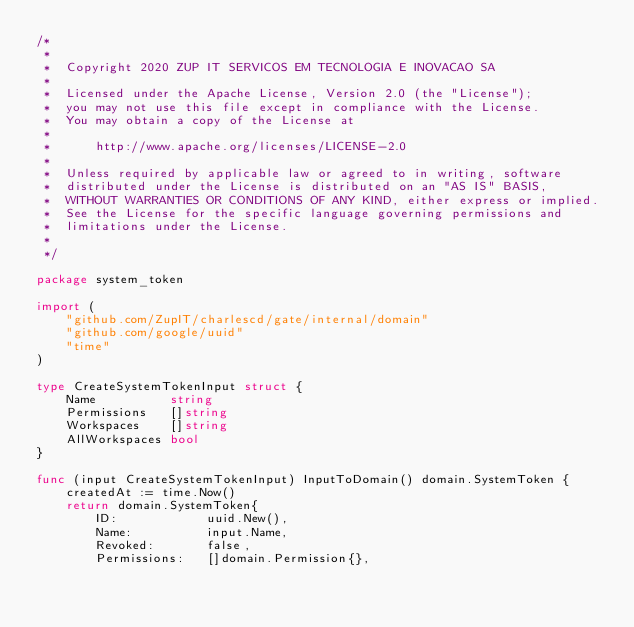<code> <loc_0><loc_0><loc_500><loc_500><_Go_>/*
 *
 *  Copyright 2020 ZUP IT SERVICOS EM TECNOLOGIA E INOVACAO SA
 *
 *  Licensed under the Apache License, Version 2.0 (the "License");
 *  you may not use this file except in compliance with the License.
 *  You may obtain a copy of the License at
 *
 *      http://www.apache.org/licenses/LICENSE-2.0
 *
 *  Unless required by applicable law or agreed to in writing, software
 *  distributed under the License is distributed on an "AS IS" BASIS,
 *  WITHOUT WARRANTIES OR CONDITIONS OF ANY KIND, either express or implied.
 *  See the License for the specific language governing permissions and
 *  limitations under the License.
 *
 */

package system_token

import (
	"github.com/ZupIT/charlescd/gate/internal/domain"
	"github.com/google/uuid"
	"time"
)

type CreateSystemTokenInput struct {
	Name          string
	Permissions   []string
	Workspaces    []string
	AllWorkspaces bool
}

func (input CreateSystemTokenInput) InputToDomain() domain.SystemToken {
	createdAt := time.Now()
	return domain.SystemToken{
		ID:            uuid.New(),
		Name:          input.Name,
		Revoked:       false,
		Permissions:   []domain.Permission{},</code> 